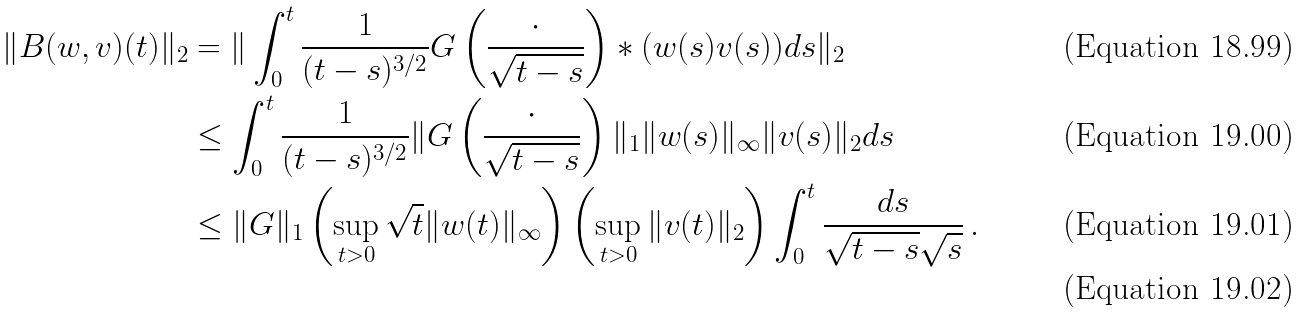<formula> <loc_0><loc_0><loc_500><loc_500>\| B ( w , v ) ( t ) \| _ { 2 } & = \| \int _ { 0 } ^ { t } \frac { 1 } { ( t - s ) ^ { 3 / 2 } } G \left ( \frac { \cdot } { \sqrt { t - s } } \right ) \ast ( w ( s ) v ( s ) ) d s \| _ { 2 } \\ & \leq \int _ { 0 } ^ { t } \frac { 1 } { ( t - s ) ^ { 3 / 2 } } \| G \left ( \frac { \cdot } { \sqrt { t - s } } \right ) \| _ { 1 } \| w ( s ) \| _ { \infty } \| v ( s ) \| _ { 2 } d s \\ & \leq \| G \| _ { 1 } \left ( \sup _ { t > 0 } \sqrt { t } \| w ( t ) \| _ { \infty } \right ) \left ( \sup _ { t > 0 } \| v ( t ) \| _ { 2 } \right ) \int _ { 0 } ^ { t } \frac { d s } { \sqrt { t - s } \sqrt { s } } \, . \\</formula> 